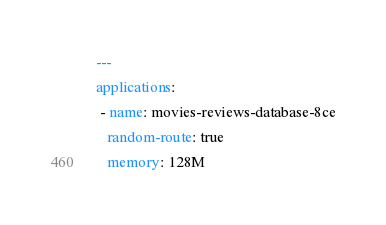<code> <loc_0><loc_0><loc_500><loc_500><_YAML_>---
applications:
 - name: movies-reviews-database-8ce
   random-route: true
   memory: 128M
</code> 